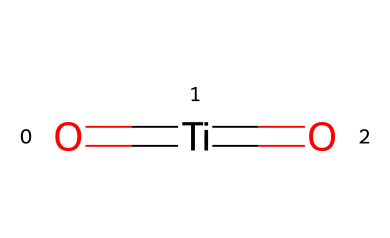What is the central atom in this molecule? By examining the SMILES representation, the central atom is titanium (Ti), which is indicated by its position within the structure.
Answer: titanium How many oxygen atoms are present in this chemical? The SMILES representation shows two instances of oxygen (O), as there are two double bonds to oxygen atoms attached to the titanium atom.
Answer: two What type of bonds are present in this molecule? The structure contains double bonds (showing the '=' signs), which indicates that there are double bonds between the titanium and oxygen atoms.
Answer: double bonds What is the oxidation state of titanium in this molecule? Considering the oxidation state of oxygen is usually -2 and there are two oxygen atoms, the total charge contribution from oxygen is -4. Since the molecule is neutral, titanium must be +4.
Answer: +4 What makes titanium dioxide a suitable photocatalyst? The presence of titanium and its ability to absorb ultraviolet light allows for the generation of reactive species that can initiate chemical reactions.
Answer: reactive species What structural characteristic enables titanium dioxide to have photocatalytic properties? The arrangement of titanium surrounded by oxygen allows for a bandgap that enables it to absorb light energy and promote electron transfer processes.
Answer: bandgap 